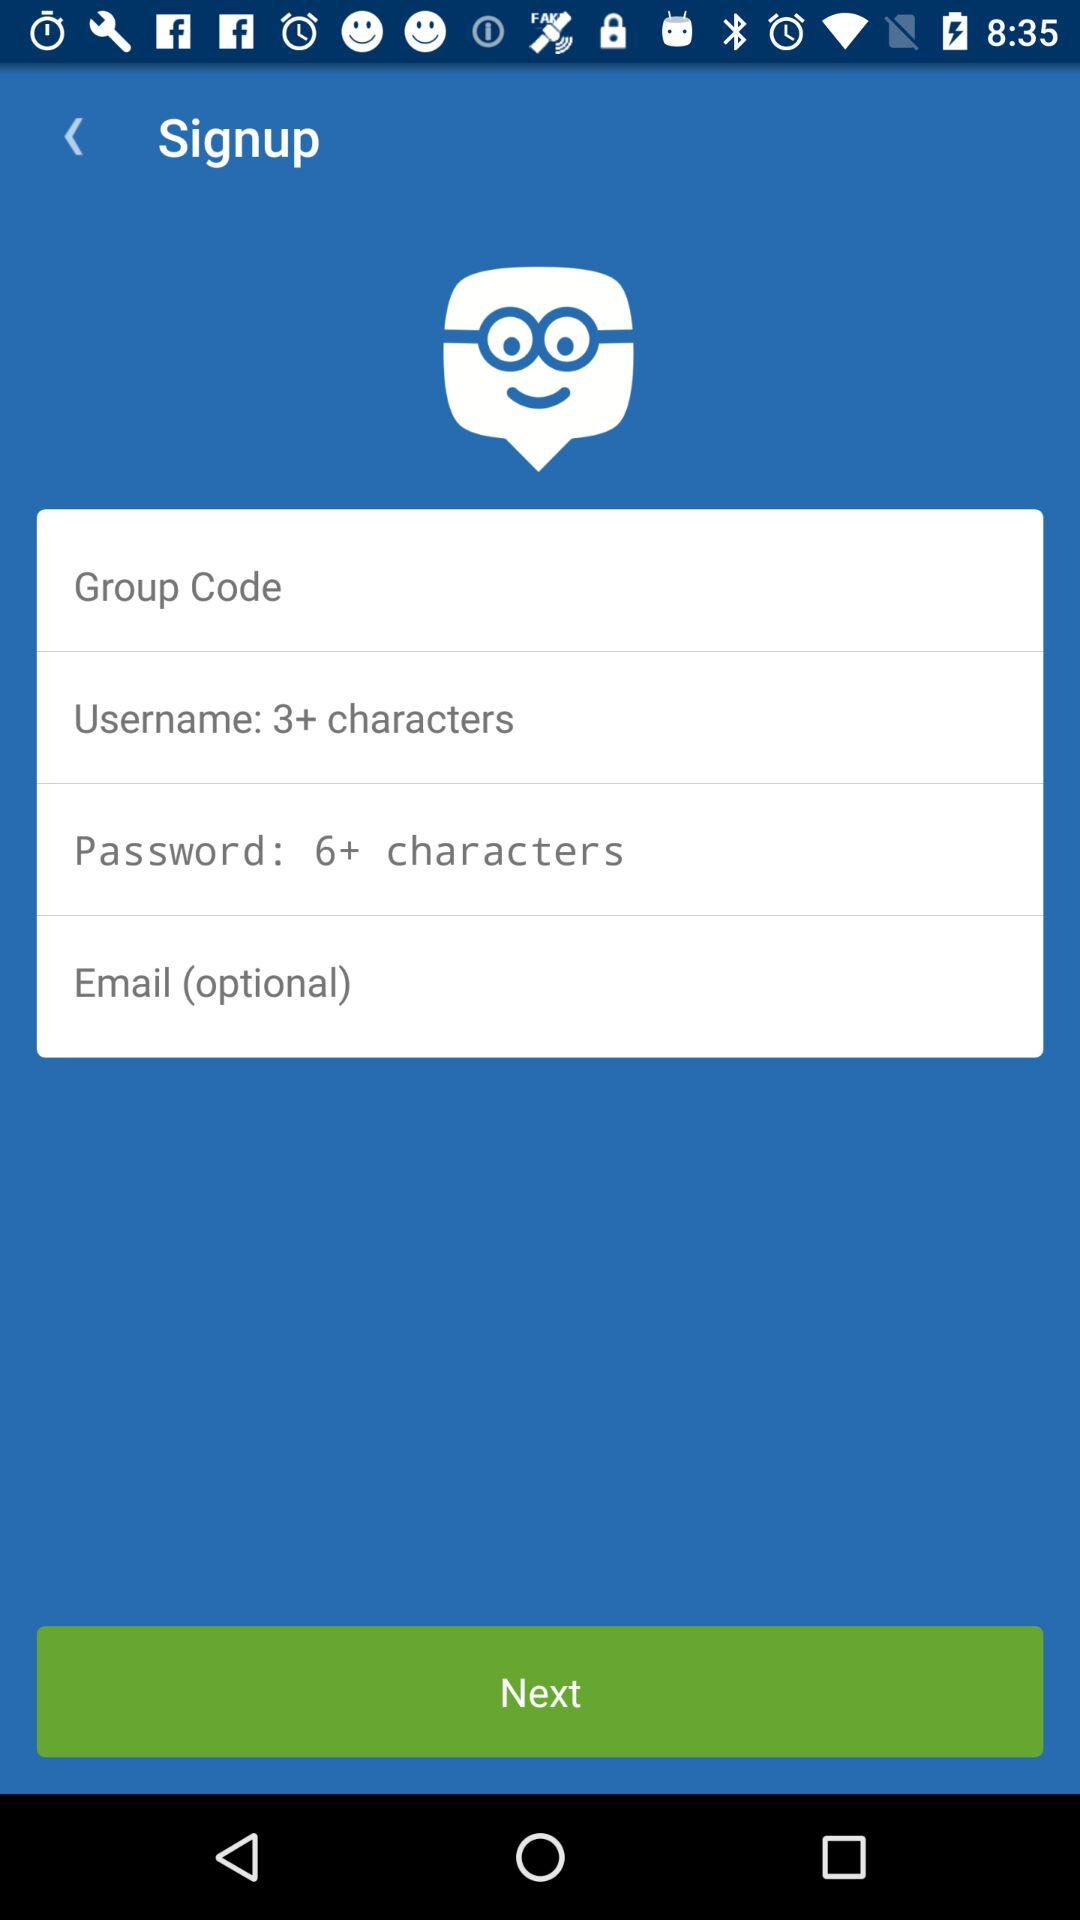How many characters are required in the username? The number of characters required in the username is 3+. 